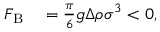Convert formula to latex. <formula><loc_0><loc_0><loc_500><loc_500>\begin{array} { r l } { F _ { B } } & = \frac { \pi } { 6 } g \Delta \rho \sigma ^ { 3 } < 0 , } \end{array}</formula> 